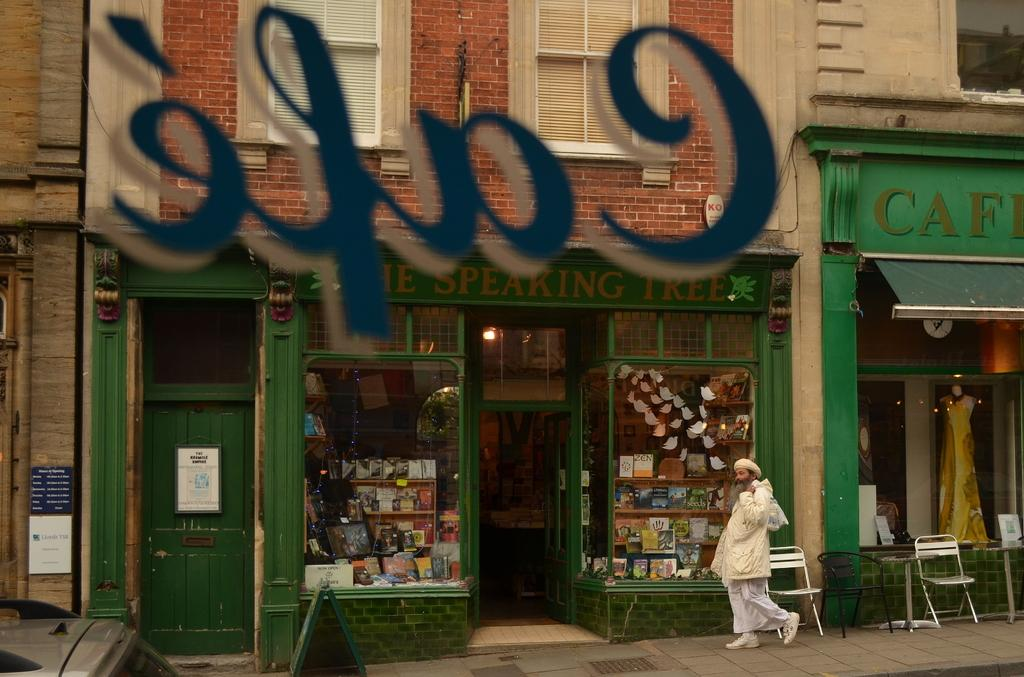Provide a one-sentence caption for the provided image. an image of a storefront of a cafe, with a women dressed in all white walking by. 